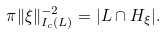<formula> <loc_0><loc_0><loc_500><loc_500>\pi \| \xi \| _ { I _ { c } ( L ) } ^ { - 2 } = | L \cap H _ { \xi } | .</formula> 